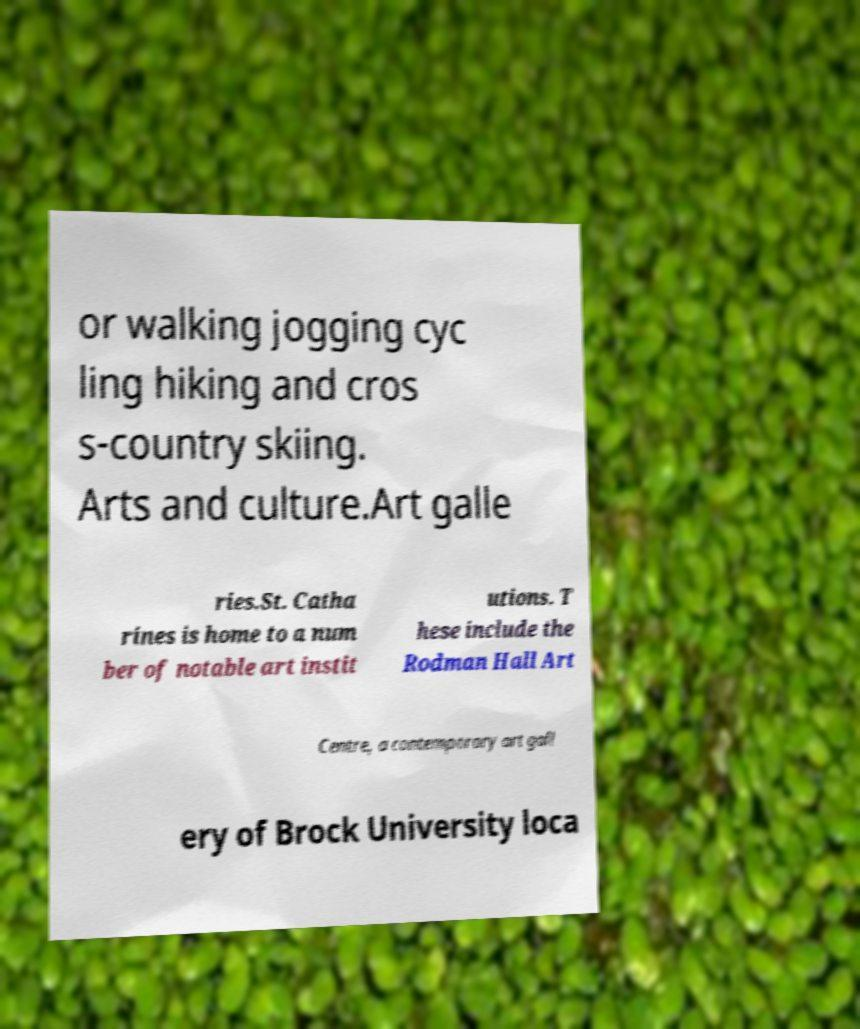Could you extract and type out the text from this image? or walking jogging cyc ling hiking and cros s-country skiing. Arts and culture.Art galle ries.St. Catha rines is home to a num ber of notable art instit utions. T hese include the Rodman Hall Art Centre, a contemporary art gall ery of Brock University loca 